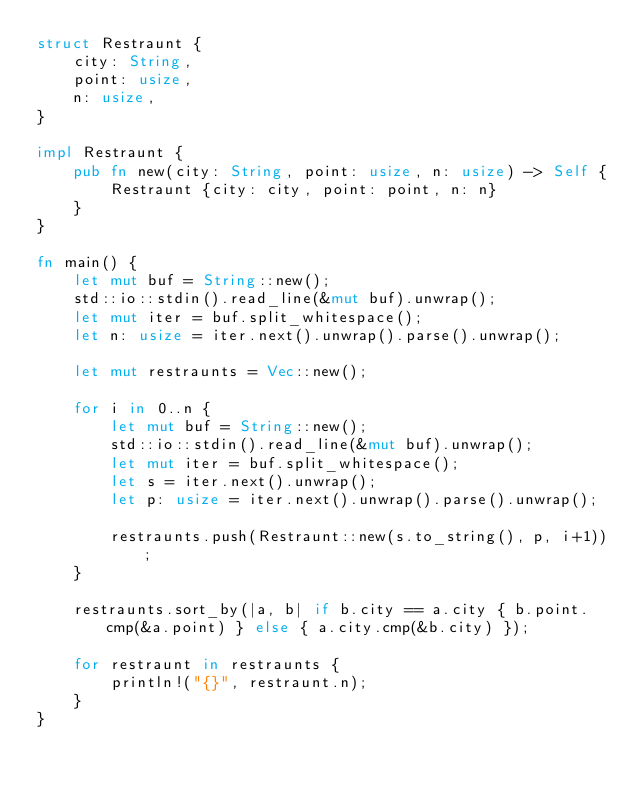<code> <loc_0><loc_0><loc_500><loc_500><_Rust_>struct Restraunt {
    city: String,
    point: usize,
    n: usize,
}

impl Restraunt {
    pub fn new(city: String, point: usize, n: usize) -> Self {
        Restraunt {city: city, point: point, n: n}
    }
}

fn main() {
    let mut buf = String::new();
    std::io::stdin().read_line(&mut buf).unwrap();
    let mut iter = buf.split_whitespace();
    let n: usize = iter.next().unwrap().parse().unwrap();

    let mut restraunts = Vec::new();

    for i in 0..n {
        let mut buf = String::new();
        std::io::stdin().read_line(&mut buf).unwrap();
        let mut iter = buf.split_whitespace();
        let s = iter.next().unwrap();
        let p: usize = iter.next().unwrap().parse().unwrap();

        restraunts.push(Restraunt::new(s.to_string(), p, i+1));
    }

    restraunts.sort_by(|a, b| if b.city == a.city { b.point.cmp(&a.point) } else { a.city.cmp(&b.city) });

    for restraunt in restraunts {
        println!("{}", restraunt.n);
    }
}
</code> 